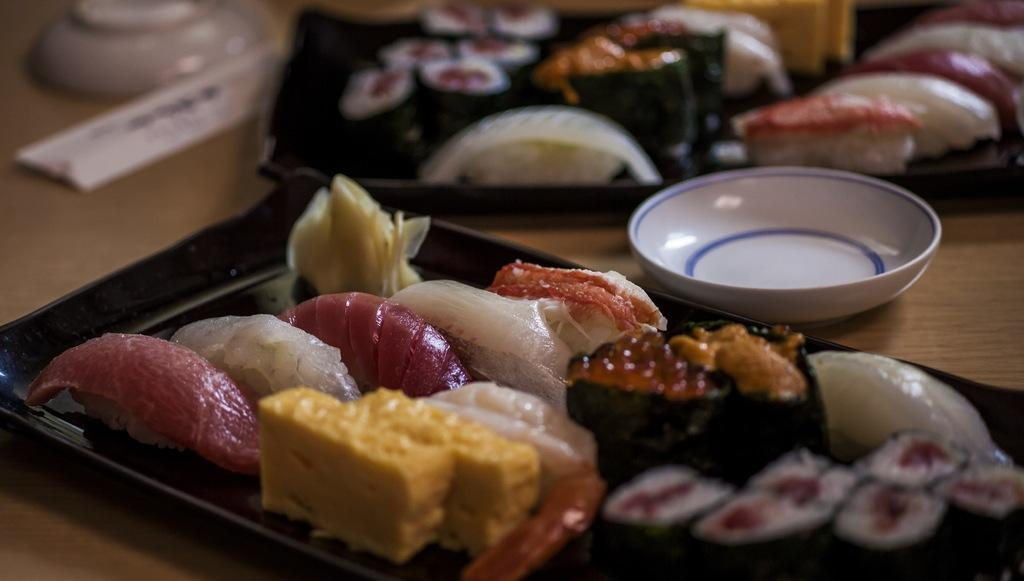What piece of furniture is present in the image? There is a table in the image. What is placed on the table? There are trays on the table. What is inside the trays? There is food in the trays. What type of containers can be seen in the image? There are bowls in the image. How many girls are sitting on the leather couch in the image? There is no leather couch or girls present in the image. 